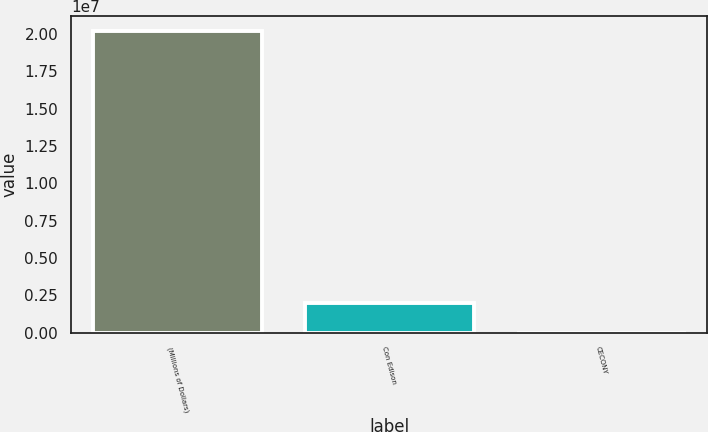Convert chart. <chart><loc_0><loc_0><loc_500><loc_500><bar_chart><fcel>(Millions of Dollars)<fcel>Con Edison<fcel>CECONY<nl><fcel>2.0202e+07<fcel>2.02053e+06<fcel>364<nl></chart> 